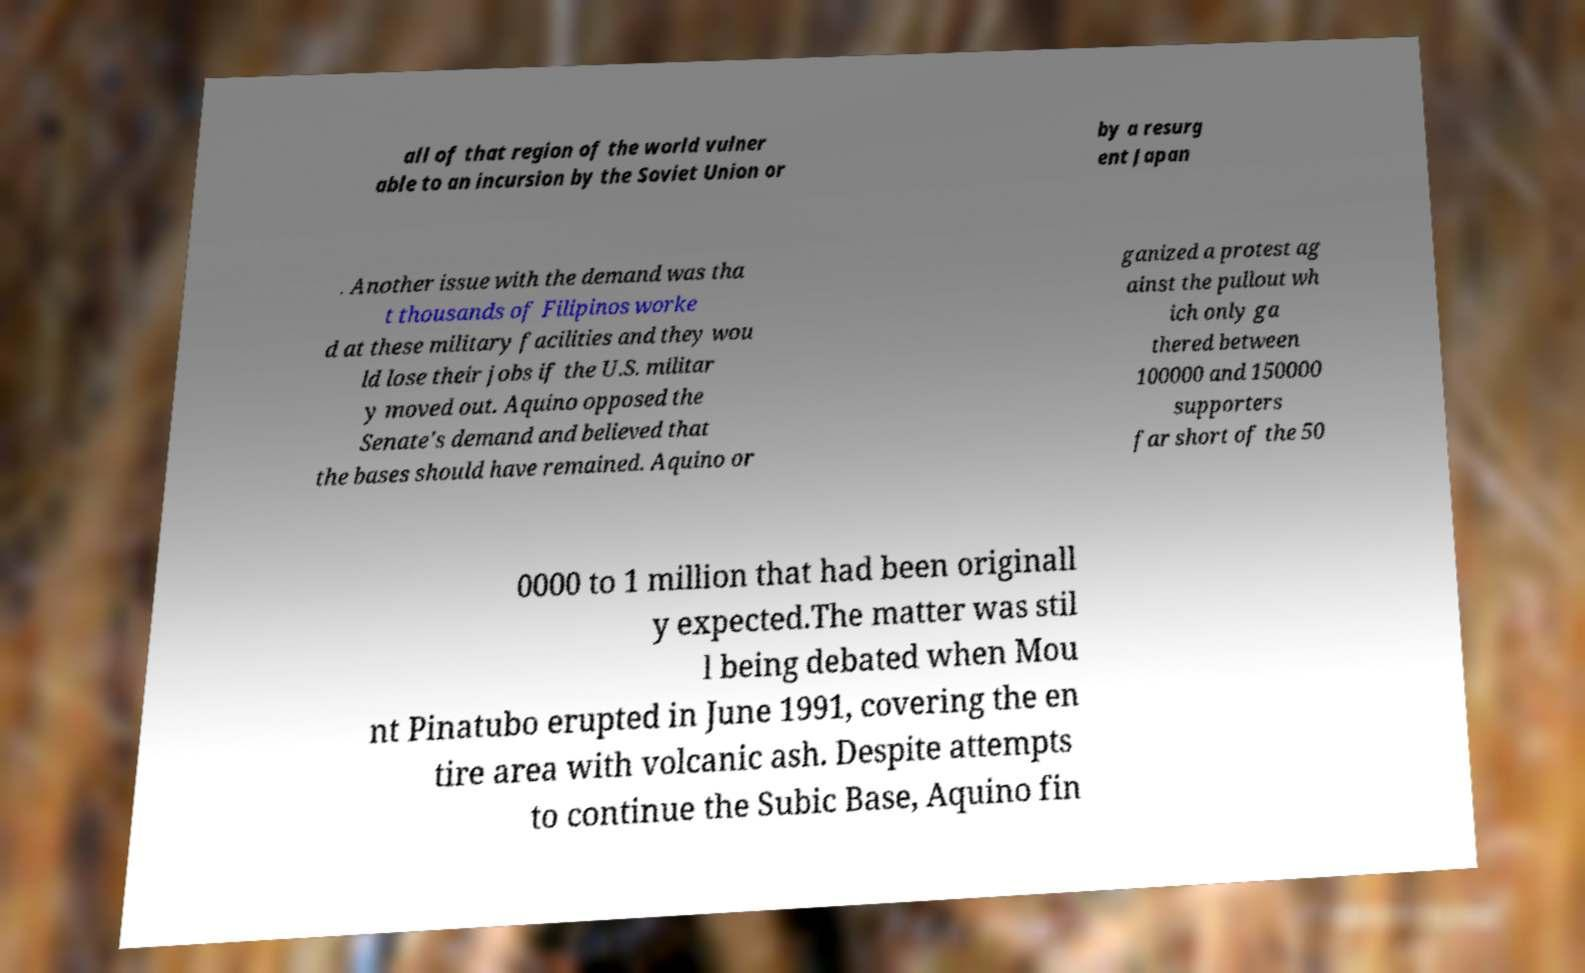Could you assist in decoding the text presented in this image and type it out clearly? all of that region of the world vulner able to an incursion by the Soviet Union or by a resurg ent Japan . Another issue with the demand was tha t thousands of Filipinos worke d at these military facilities and they wou ld lose their jobs if the U.S. militar y moved out. Aquino opposed the Senate's demand and believed that the bases should have remained. Aquino or ganized a protest ag ainst the pullout wh ich only ga thered between 100000 and 150000 supporters far short of the 50 0000 to 1 million that had been originall y expected.The matter was stil l being debated when Mou nt Pinatubo erupted in June 1991, covering the en tire area with volcanic ash. Despite attempts to continue the Subic Base, Aquino fin 